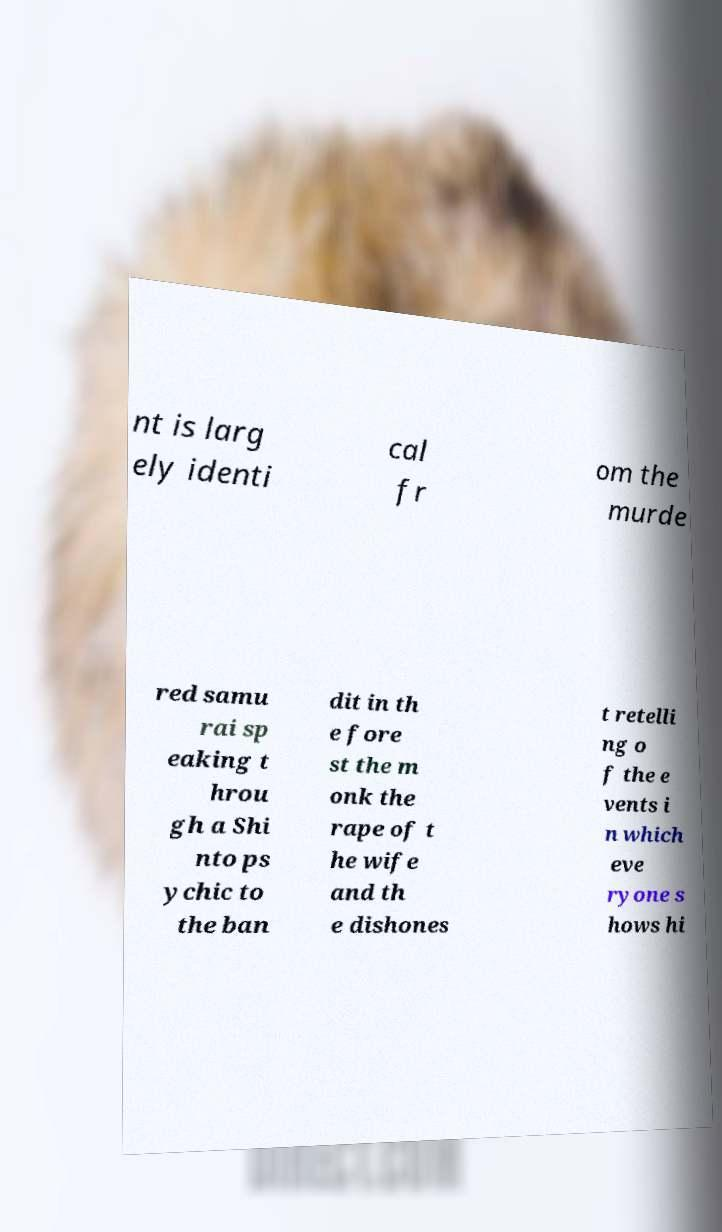Could you assist in decoding the text presented in this image and type it out clearly? nt is larg ely identi cal fr om the murde red samu rai sp eaking t hrou gh a Shi nto ps ychic to the ban dit in th e fore st the m onk the rape of t he wife and th e dishones t retelli ng o f the e vents i n which eve ryone s hows hi 